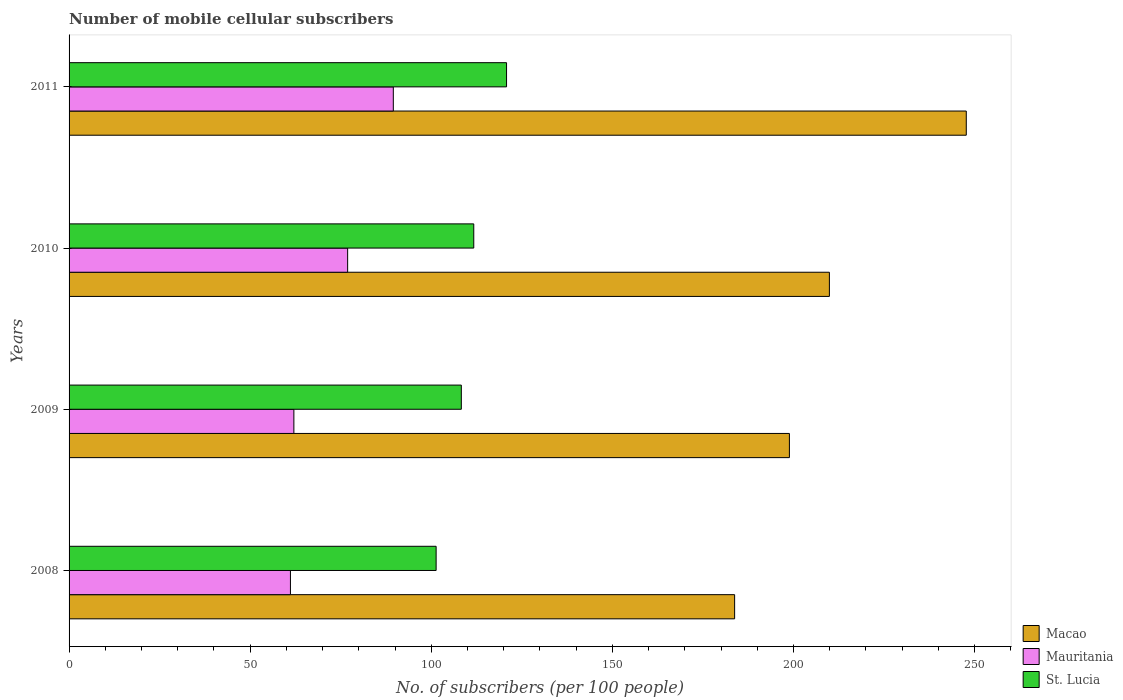How many different coloured bars are there?
Make the answer very short. 3. How many bars are there on the 4th tick from the bottom?
Give a very brief answer. 3. In how many cases, is the number of bars for a given year not equal to the number of legend labels?
Provide a short and direct response. 0. What is the number of mobile cellular subscribers in Macao in 2008?
Your answer should be very brief. 183.75. Across all years, what is the maximum number of mobile cellular subscribers in Macao?
Ensure brevity in your answer.  247.71. Across all years, what is the minimum number of mobile cellular subscribers in Macao?
Give a very brief answer. 183.75. What is the total number of mobile cellular subscribers in Mauritania in the graph?
Your answer should be very brief. 289.62. What is the difference between the number of mobile cellular subscribers in Mauritania in 2008 and that in 2009?
Your answer should be very brief. -0.95. What is the difference between the number of mobile cellular subscribers in Mauritania in 2011 and the number of mobile cellular subscribers in Macao in 2008?
Keep it short and to the point. -94.23. What is the average number of mobile cellular subscribers in Mauritania per year?
Make the answer very short. 72.4. In the year 2010, what is the difference between the number of mobile cellular subscribers in Mauritania and number of mobile cellular subscribers in St. Lucia?
Give a very brief answer. -34.82. In how many years, is the number of mobile cellular subscribers in St. Lucia greater than 200 ?
Make the answer very short. 0. What is the ratio of the number of mobile cellular subscribers in St. Lucia in 2008 to that in 2011?
Offer a terse response. 0.84. Is the number of mobile cellular subscribers in St. Lucia in 2010 less than that in 2011?
Provide a short and direct response. Yes. Is the difference between the number of mobile cellular subscribers in Mauritania in 2008 and 2010 greater than the difference between the number of mobile cellular subscribers in St. Lucia in 2008 and 2010?
Offer a very short reply. No. What is the difference between the highest and the second highest number of mobile cellular subscribers in St. Lucia?
Provide a short and direct response. 9.05. What is the difference between the highest and the lowest number of mobile cellular subscribers in St. Lucia?
Offer a very short reply. 19.45. In how many years, is the number of mobile cellular subscribers in St. Lucia greater than the average number of mobile cellular subscribers in St. Lucia taken over all years?
Offer a terse response. 2. What does the 1st bar from the top in 2010 represents?
Provide a short and direct response. St. Lucia. What does the 3rd bar from the bottom in 2011 represents?
Your response must be concise. St. Lucia. Are all the bars in the graph horizontal?
Offer a terse response. Yes. What is the difference between two consecutive major ticks on the X-axis?
Your answer should be compact. 50. Are the values on the major ticks of X-axis written in scientific E-notation?
Your response must be concise. No. Does the graph contain any zero values?
Provide a succinct answer. No. How many legend labels are there?
Make the answer very short. 3. What is the title of the graph?
Keep it short and to the point. Number of mobile cellular subscribers. What is the label or title of the X-axis?
Keep it short and to the point. No. of subscribers (per 100 people). What is the label or title of the Y-axis?
Keep it short and to the point. Years. What is the No. of subscribers (per 100 people) in Macao in 2008?
Offer a very short reply. 183.75. What is the No. of subscribers (per 100 people) in Mauritania in 2008?
Provide a succinct answer. 61.12. What is the No. of subscribers (per 100 people) in St. Lucia in 2008?
Provide a succinct answer. 101.34. What is the No. of subscribers (per 100 people) of Macao in 2009?
Your answer should be compact. 198.88. What is the No. of subscribers (per 100 people) in Mauritania in 2009?
Your answer should be very brief. 62.06. What is the No. of subscribers (per 100 people) of St. Lucia in 2009?
Ensure brevity in your answer.  108.3. What is the No. of subscribers (per 100 people) in Macao in 2010?
Offer a terse response. 209.92. What is the No. of subscribers (per 100 people) of Mauritania in 2010?
Give a very brief answer. 76.91. What is the No. of subscribers (per 100 people) in St. Lucia in 2010?
Keep it short and to the point. 111.73. What is the No. of subscribers (per 100 people) in Macao in 2011?
Offer a very short reply. 247.71. What is the No. of subscribers (per 100 people) in Mauritania in 2011?
Ensure brevity in your answer.  89.52. What is the No. of subscribers (per 100 people) of St. Lucia in 2011?
Provide a succinct answer. 120.78. Across all years, what is the maximum No. of subscribers (per 100 people) of Macao?
Your answer should be compact. 247.71. Across all years, what is the maximum No. of subscribers (per 100 people) in Mauritania?
Your answer should be very brief. 89.52. Across all years, what is the maximum No. of subscribers (per 100 people) of St. Lucia?
Make the answer very short. 120.78. Across all years, what is the minimum No. of subscribers (per 100 people) of Macao?
Provide a short and direct response. 183.75. Across all years, what is the minimum No. of subscribers (per 100 people) in Mauritania?
Provide a succinct answer. 61.12. Across all years, what is the minimum No. of subscribers (per 100 people) of St. Lucia?
Make the answer very short. 101.34. What is the total No. of subscribers (per 100 people) of Macao in the graph?
Offer a terse response. 840.26. What is the total No. of subscribers (per 100 people) in Mauritania in the graph?
Offer a very short reply. 289.62. What is the total No. of subscribers (per 100 people) of St. Lucia in the graph?
Your response must be concise. 442.15. What is the difference between the No. of subscribers (per 100 people) in Macao in 2008 and that in 2009?
Offer a terse response. -15.13. What is the difference between the No. of subscribers (per 100 people) of Mauritania in 2008 and that in 2009?
Provide a succinct answer. -0.95. What is the difference between the No. of subscribers (per 100 people) of St. Lucia in 2008 and that in 2009?
Give a very brief answer. -6.96. What is the difference between the No. of subscribers (per 100 people) of Macao in 2008 and that in 2010?
Your response must be concise. -26.16. What is the difference between the No. of subscribers (per 100 people) in Mauritania in 2008 and that in 2010?
Your answer should be compact. -15.79. What is the difference between the No. of subscribers (per 100 people) of St. Lucia in 2008 and that in 2010?
Offer a very short reply. -10.4. What is the difference between the No. of subscribers (per 100 people) in Macao in 2008 and that in 2011?
Keep it short and to the point. -63.96. What is the difference between the No. of subscribers (per 100 people) of Mauritania in 2008 and that in 2011?
Your response must be concise. -28.4. What is the difference between the No. of subscribers (per 100 people) in St. Lucia in 2008 and that in 2011?
Your response must be concise. -19.45. What is the difference between the No. of subscribers (per 100 people) in Macao in 2009 and that in 2010?
Offer a very short reply. -11.04. What is the difference between the No. of subscribers (per 100 people) of Mauritania in 2009 and that in 2010?
Ensure brevity in your answer.  -14.85. What is the difference between the No. of subscribers (per 100 people) in St. Lucia in 2009 and that in 2010?
Offer a very short reply. -3.44. What is the difference between the No. of subscribers (per 100 people) in Macao in 2009 and that in 2011?
Your answer should be very brief. -48.83. What is the difference between the No. of subscribers (per 100 people) of Mauritania in 2009 and that in 2011?
Offer a terse response. -27.46. What is the difference between the No. of subscribers (per 100 people) in St. Lucia in 2009 and that in 2011?
Ensure brevity in your answer.  -12.49. What is the difference between the No. of subscribers (per 100 people) of Macao in 2010 and that in 2011?
Your response must be concise. -37.8. What is the difference between the No. of subscribers (per 100 people) in Mauritania in 2010 and that in 2011?
Give a very brief answer. -12.61. What is the difference between the No. of subscribers (per 100 people) in St. Lucia in 2010 and that in 2011?
Your response must be concise. -9.05. What is the difference between the No. of subscribers (per 100 people) of Macao in 2008 and the No. of subscribers (per 100 people) of Mauritania in 2009?
Make the answer very short. 121.69. What is the difference between the No. of subscribers (per 100 people) of Macao in 2008 and the No. of subscribers (per 100 people) of St. Lucia in 2009?
Make the answer very short. 75.45. What is the difference between the No. of subscribers (per 100 people) in Mauritania in 2008 and the No. of subscribers (per 100 people) in St. Lucia in 2009?
Provide a succinct answer. -47.18. What is the difference between the No. of subscribers (per 100 people) in Macao in 2008 and the No. of subscribers (per 100 people) in Mauritania in 2010?
Give a very brief answer. 106.84. What is the difference between the No. of subscribers (per 100 people) in Macao in 2008 and the No. of subscribers (per 100 people) in St. Lucia in 2010?
Make the answer very short. 72.02. What is the difference between the No. of subscribers (per 100 people) in Mauritania in 2008 and the No. of subscribers (per 100 people) in St. Lucia in 2010?
Make the answer very short. -50.62. What is the difference between the No. of subscribers (per 100 people) of Macao in 2008 and the No. of subscribers (per 100 people) of Mauritania in 2011?
Give a very brief answer. 94.23. What is the difference between the No. of subscribers (per 100 people) of Macao in 2008 and the No. of subscribers (per 100 people) of St. Lucia in 2011?
Your response must be concise. 62.97. What is the difference between the No. of subscribers (per 100 people) of Mauritania in 2008 and the No. of subscribers (per 100 people) of St. Lucia in 2011?
Provide a short and direct response. -59.67. What is the difference between the No. of subscribers (per 100 people) in Macao in 2009 and the No. of subscribers (per 100 people) in Mauritania in 2010?
Offer a terse response. 121.97. What is the difference between the No. of subscribers (per 100 people) in Macao in 2009 and the No. of subscribers (per 100 people) in St. Lucia in 2010?
Ensure brevity in your answer.  87.14. What is the difference between the No. of subscribers (per 100 people) of Mauritania in 2009 and the No. of subscribers (per 100 people) of St. Lucia in 2010?
Ensure brevity in your answer.  -49.67. What is the difference between the No. of subscribers (per 100 people) in Macao in 2009 and the No. of subscribers (per 100 people) in Mauritania in 2011?
Keep it short and to the point. 109.36. What is the difference between the No. of subscribers (per 100 people) of Macao in 2009 and the No. of subscribers (per 100 people) of St. Lucia in 2011?
Give a very brief answer. 78.09. What is the difference between the No. of subscribers (per 100 people) in Mauritania in 2009 and the No. of subscribers (per 100 people) in St. Lucia in 2011?
Provide a succinct answer. -58.72. What is the difference between the No. of subscribers (per 100 people) in Macao in 2010 and the No. of subscribers (per 100 people) in Mauritania in 2011?
Give a very brief answer. 120.39. What is the difference between the No. of subscribers (per 100 people) of Macao in 2010 and the No. of subscribers (per 100 people) of St. Lucia in 2011?
Provide a succinct answer. 89.13. What is the difference between the No. of subscribers (per 100 people) in Mauritania in 2010 and the No. of subscribers (per 100 people) in St. Lucia in 2011?
Keep it short and to the point. -43.87. What is the average No. of subscribers (per 100 people) of Macao per year?
Provide a short and direct response. 210.06. What is the average No. of subscribers (per 100 people) in Mauritania per year?
Ensure brevity in your answer.  72.4. What is the average No. of subscribers (per 100 people) in St. Lucia per year?
Keep it short and to the point. 110.54. In the year 2008, what is the difference between the No. of subscribers (per 100 people) of Macao and No. of subscribers (per 100 people) of Mauritania?
Your answer should be very brief. 122.64. In the year 2008, what is the difference between the No. of subscribers (per 100 people) in Macao and No. of subscribers (per 100 people) in St. Lucia?
Offer a very short reply. 82.41. In the year 2008, what is the difference between the No. of subscribers (per 100 people) of Mauritania and No. of subscribers (per 100 people) of St. Lucia?
Offer a very short reply. -40.22. In the year 2009, what is the difference between the No. of subscribers (per 100 people) of Macao and No. of subscribers (per 100 people) of Mauritania?
Offer a terse response. 136.81. In the year 2009, what is the difference between the No. of subscribers (per 100 people) of Macao and No. of subscribers (per 100 people) of St. Lucia?
Offer a very short reply. 90.58. In the year 2009, what is the difference between the No. of subscribers (per 100 people) of Mauritania and No. of subscribers (per 100 people) of St. Lucia?
Ensure brevity in your answer.  -46.23. In the year 2010, what is the difference between the No. of subscribers (per 100 people) in Macao and No. of subscribers (per 100 people) in Mauritania?
Offer a very short reply. 133. In the year 2010, what is the difference between the No. of subscribers (per 100 people) of Macao and No. of subscribers (per 100 people) of St. Lucia?
Offer a terse response. 98.18. In the year 2010, what is the difference between the No. of subscribers (per 100 people) of Mauritania and No. of subscribers (per 100 people) of St. Lucia?
Provide a short and direct response. -34.82. In the year 2011, what is the difference between the No. of subscribers (per 100 people) in Macao and No. of subscribers (per 100 people) in Mauritania?
Your response must be concise. 158.19. In the year 2011, what is the difference between the No. of subscribers (per 100 people) of Macao and No. of subscribers (per 100 people) of St. Lucia?
Provide a short and direct response. 126.93. In the year 2011, what is the difference between the No. of subscribers (per 100 people) in Mauritania and No. of subscribers (per 100 people) in St. Lucia?
Ensure brevity in your answer.  -31.26. What is the ratio of the No. of subscribers (per 100 people) in Macao in 2008 to that in 2009?
Make the answer very short. 0.92. What is the ratio of the No. of subscribers (per 100 people) of Mauritania in 2008 to that in 2009?
Your answer should be very brief. 0.98. What is the ratio of the No. of subscribers (per 100 people) of St. Lucia in 2008 to that in 2009?
Make the answer very short. 0.94. What is the ratio of the No. of subscribers (per 100 people) of Macao in 2008 to that in 2010?
Make the answer very short. 0.88. What is the ratio of the No. of subscribers (per 100 people) in Mauritania in 2008 to that in 2010?
Offer a very short reply. 0.79. What is the ratio of the No. of subscribers (per 100 people) of St. Lucia in 2008 to that in 2010?
Offer a very short reply. 0.91. What is the ratio of the No. of subscribers (per 100 people) of Macao in 2008 to that in 2011?
Offer a very short reply. 0.74. What is the ratio of the No. of subscribers (per 100 people) of Mauritania in 2008 to that in 2011?
Make the answer very short. 0.68. What is the ratio of the No. of subscribers (per 100 people) of St. Lucia in 2008 to that in 2011?
Keep it short and to the point. 0.84. What is the ratio of the No. of subscribers (per 100 people) in Macao in 2009 to that in 2010?
Provide a short and direct response. 0.95. What is the ratio of the No. of subscribers (per 100 people) of Mauritania in 2009 to that in 2010?
Your answer should be compact. 0.81. What is the ratio of the No. of subscribers (per 100 people) of St. Lucia in 2009 to that in 2010?
Ensure brevity in your answer.  0.97. What is the ratio of the No. of subscribers (per 100 people) of Macao in 2009 to that in 2011?
Provide a short and direct response. 0.8. What is the ratio of the No. of subscribers (per 100 people) in Mauritania in 2009 to that in 2011?
Offer a terse response. 0.69. What is the ratio of the No. of subscribers (per 100 people) of St. Lucia in 2009 to that in 2011?
Make the answer very short. 0.9. What is the ratio of the No. of subscribers (per 100 people) of Macao in 2010 to that in 2011?
Your response must be concise. 0.85. What is the ratio of the No. of subscribers (per 100 people) in Mauritania in 2010 to that in 2011?
Give a very brief answer. 0.86. What is the ratio of the No. of subscribers (per 100 people) in St. Lucia in 2010 to that in 2011?
Ensure brevity in your answer.  0.93. What is the difference between the highest and the second highest No. of subscribers (per 100 people) of Macao?
Your response must be concise. 37.8. What is the difference between the highest and the second highest No. of subscribers (per 100 people) of Mauritania?
Make the answer very short. 12.61. What is the difference between the highest and the second highest No. of subscribers (per 100 people) in St. Lucia?
Give a very brief answer. 9.05. What is the difference between the highest and the lowest No. of subscribers (per 100 people) of Macao?
Offer a terse response. 63.96. What is the difference between the highest and the lowest No. of subscribers (per 100 people) in Mauritania?
Offer a very short reply. 28.4. What is the difference between the highest and the lowest No. of subscribers (per 100 people) in St. Lucia?
Ensure brevity in your answer.  19.45. 